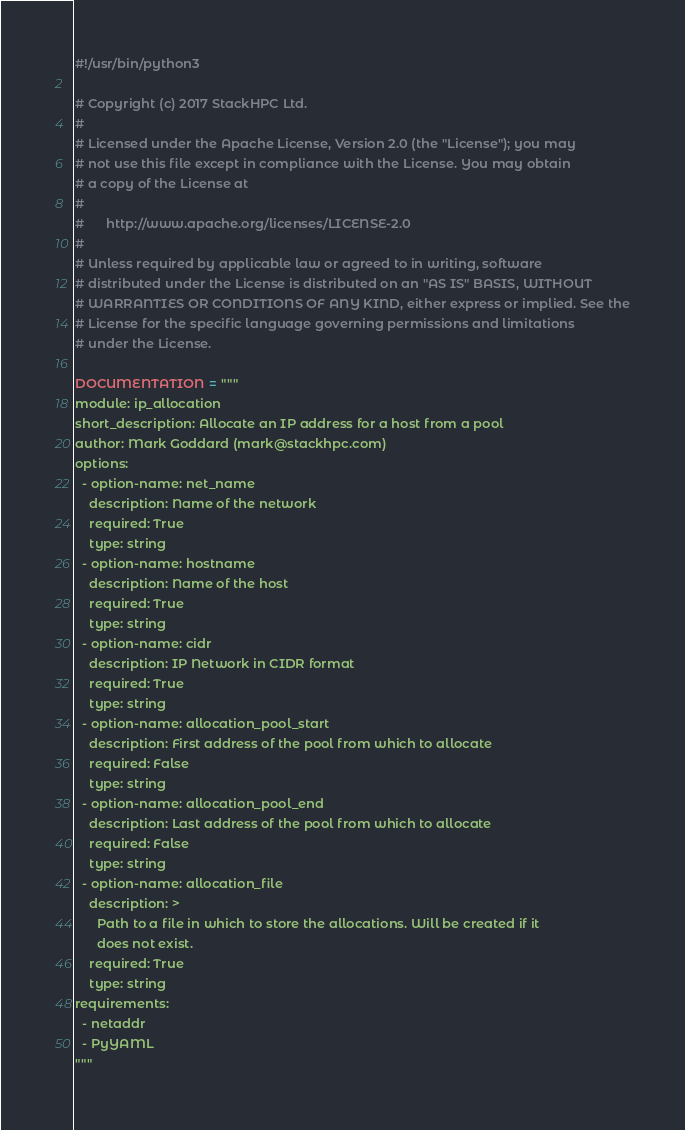<code> <loc_0><loc_0><loc_500><loc_500><_Python_>#!/usr/bin/python3

# Copyright (c) 2017 StackHPC Ltd.
#
# Licensed under the Apache License, Version 2.0 (the "License"); you may
# not use this file except in compliance with the License. You may obtain
# a copy of the License at
#
#      http://www.apache.org/licenses/LICENSE-2.0
#
# Unless required by applicable law or agreed to in writing, software
# distributed under the License is distributed on an "AS IS" BASIS, WITHOUT
# WARRANTIES OR CONDITIONS OF ANY KIND, either express or implied. See the
# License for the specific language governing permissions and limitations
# under the License.

DOCUMENTATION = """
module: ip_allocation
short_description: Allocate an IP address for a host from a pool
author: Mark Goddard (mark@stackhpc.com)
options:
  - option-name: net_name
    description: Name of the network
    required: True
    type: string
  - option-name: hostname
    description: Name of the host
    required: True
    type: string
  - option-name: cidr
    description: IP Network in CIDR format
    required: True
    type: string
  - option-name: allocation_pool_start
    description: First address of the pool from which to allocate
    required: False
    type: string
  - option-name: allocation_pool_end
    description: Last address of the pool from which to allocate
    required: False
    type: string
  - option-name: allocation_file
    description: >
      Path to a file in which to store the allocations. Will be created if it
      does not exist.
    required: True
    type: string
requirements:
  - netaddr
  - PyYAML
"""
</code> 